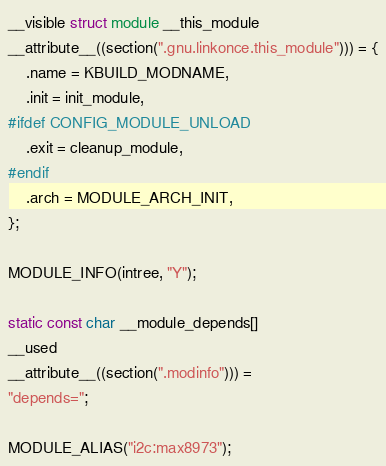Convert code to text. <code><loc_0><loc_0><loc_500><loc_500><_C_>__visible struct module __this_module
__attribute__((section(".gnu.linkonce.this_module"))) = {
	.name = KBUILD_MODNAME,
	.init = init_module,
#ifdef CONFIG_MODULE_UNLOAD
	.exit = cleanup_module,
#endif
	.arch = MODULE_ARCH_INIT,
};

MODULE_INFO(intree, "Y");

static const char __module_depends[]
__used
__attribute__((section(".modinfo"))) =
"depends=";

MODULE_ALIAS("i2c:max8973");
</code> 